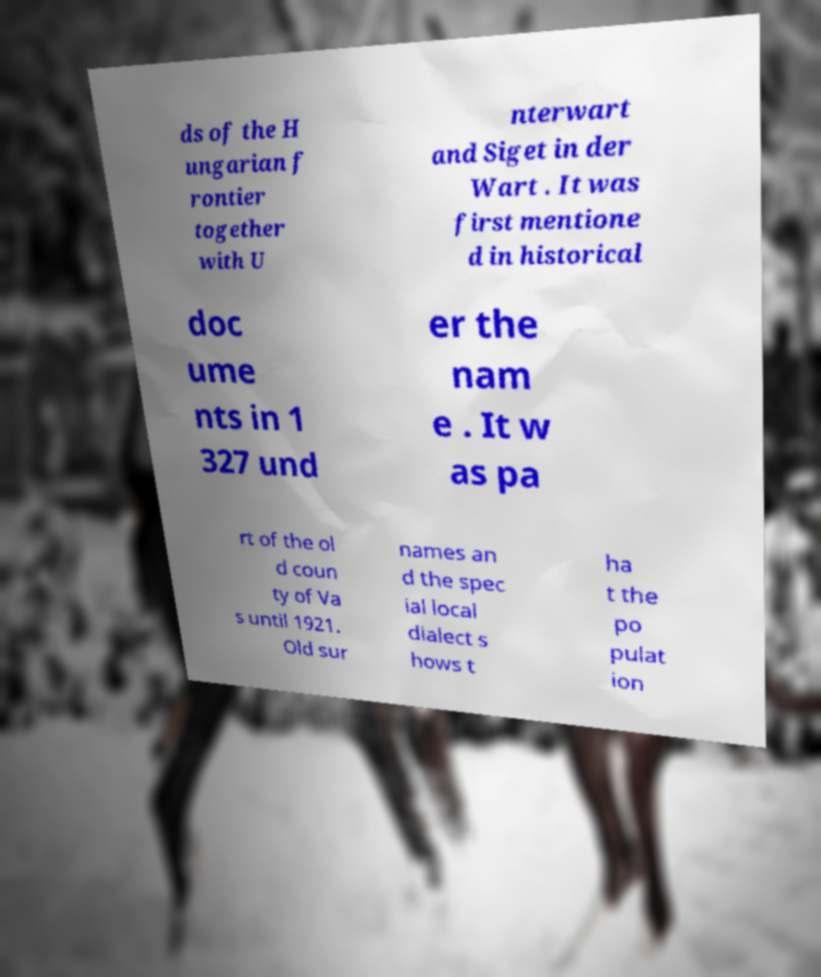Can you accurately transcribe the text from the provided image for me? ds of the H ungarian f rontier together with U nterwart and Siget in der Wart . It was first mentione d in historical doc ume nts in 1 327 und er the nam e . It w as pa rt of the ol d coun ty of Va s until 1921. Old sur names an d the spec ial local dialect s hows t ha t the po pulat ion 